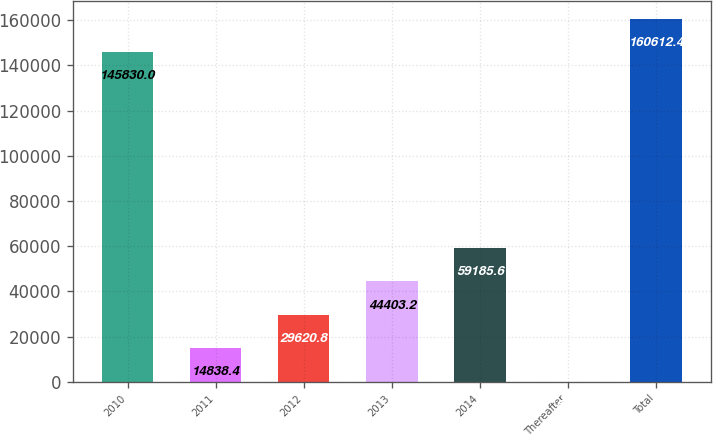Convert chart to OTSL. <chart><loc_0><loc_0><loc_500><loc_500><bar_chart><fcel>2010<fcel>2011<fcel>2012<fcel>2013<fcel>2014<fcel>Thereafter<fcel>Total<nl><fcel>145830<fcel>14838.4<fcel>29620.8<fcel>44403.2<fcel>59185.6<fcel>56<fcel>160612<nl></chart> 